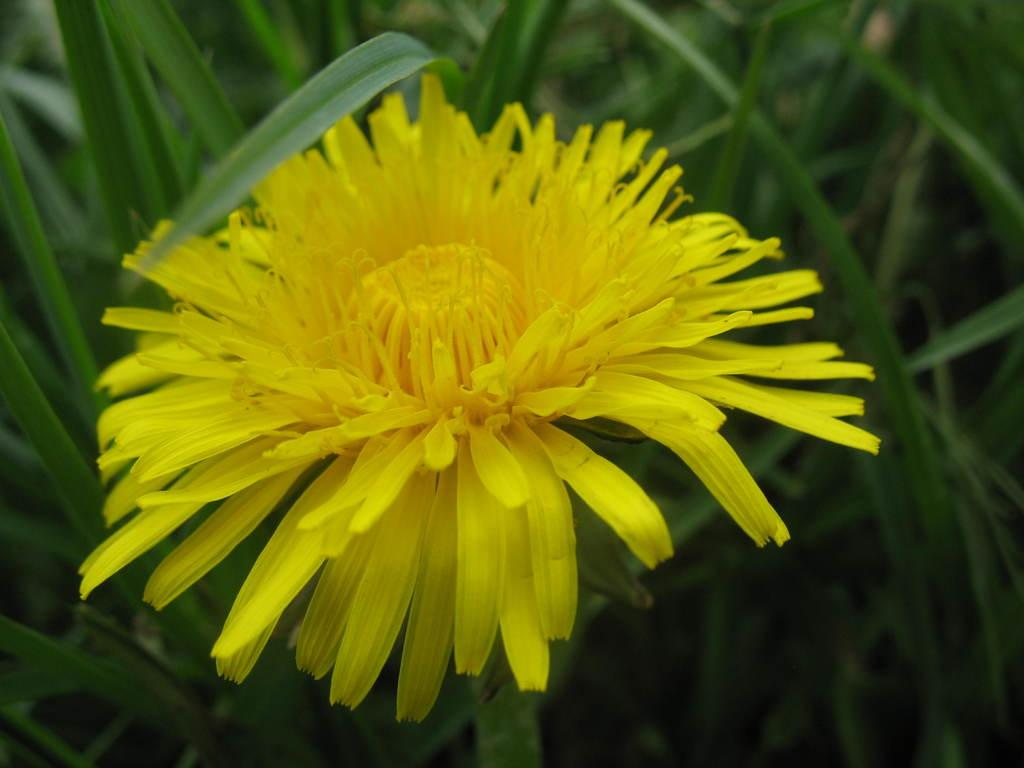What is the main subject in the center of the image? There is a yellow flower in the center of the image. What type of vegetation surrounds the main subject? There is grass around the area of the image. What type of teaching method is being demonstrated in the image? There is no teaching method present in the image; it features a yellow flower and grass. What type of furniture can be seen in the image? There is no furniture present in the image; it features a yellow flower and grass. 